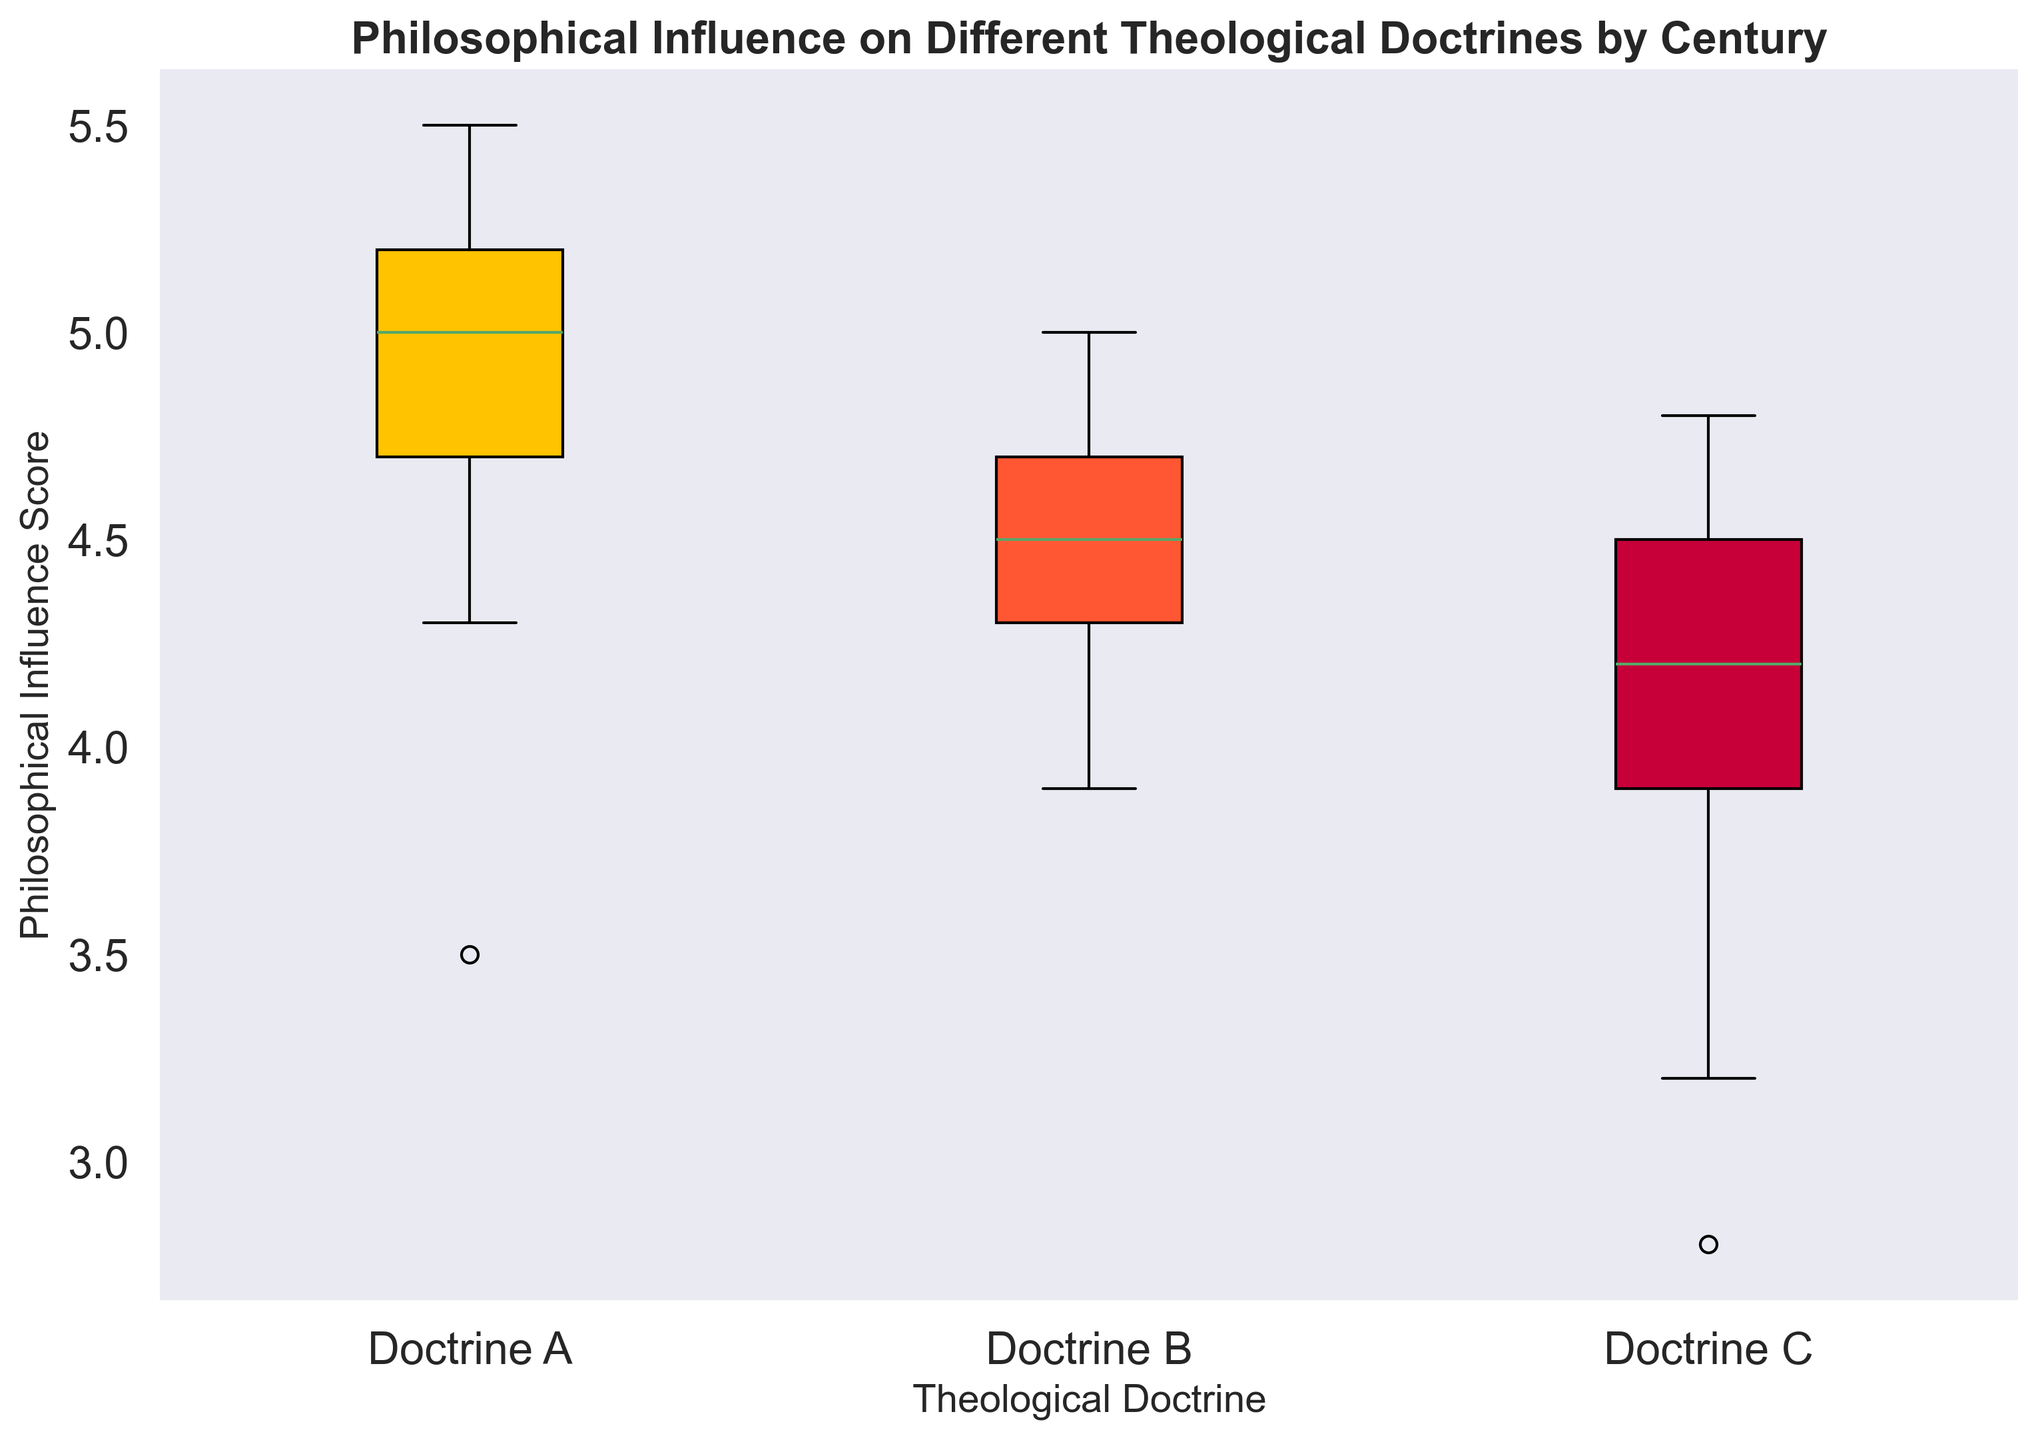Which doctrine has the highest median Philosophical Influence Score? To determine this, examine the line inside each box in the box plot, which represents the median score. Find the box with the highest median line.
Answer: Doctrine A Which doctrine has the lowest median Philosophical Influence Score? Look for the box with the lowest inner line among all the boxes. This line signifies the median score.
Answer: Doctrine C What is the range of Philosophical Influence Scores for Doctrine B? The range is determined by the distance between the top and bottom whiskers in the box plot for Doctrine B. The top whisker represents the maximum score, and the bottom whisker represents the minimum score.
Answer: 4.1 - 5.0 = 0.9 Which doctrine displays the most variability in Philosophical Influence Scores? To find the variability, observe the length of the box and whiskers for each doctrine. The doctrine with the longest box and whiskers displays the most variability.
Answer: Doctrine C Which century appears to have the highest concentration of high Philosophical Influence Scores across all doctrines? For this, identify which centuries have boxes plotted at higher positions for all their associated doctrines. Higher boxes indicate higher scores.
Answer: 21st Century How does the interquartile range (IQR) for Doctrine A compare to the IQRs for the other doctrines? The IQR is the distance between the bottom and top of the box in the box plot, representing the range of the middle 50% of the data. Compare the lengths of the boxes across all doctrines.
Answer: Doctrine A has a smaller IQR than Doctrines B and C Which doctrine consistently shows higher Philosophical Influence Scores across all centuries? To see the consistency across centuries, look at the aggregate position of the boxes across centuries. The doctrine with boxes generally higher on the graph shows higher scores.
Answer: Doctrine A Doctrines B and C in the 17th century: Which one shows a higher spread of data? Compare the lengths of the boxes and whiskers for Doctrines B and C in the 17th century. The longer the box and whiskers, the higher the spread.
Answer: Doctrine B What is the approximate median value for Doctrine A in the 18th century? Locate the box for Doctrine A in the 18th century and find the inner horizontal line (median). Estimate its value by referring to the y-axis labels.
Answer: Approximately 5.4 Which doctrine shows the least influence from philosophy in the 1st century? In the 1st century, find the box at the lowest position among all doctrines, representing the doctrine with the least influence.
Answer: Doctrine C 